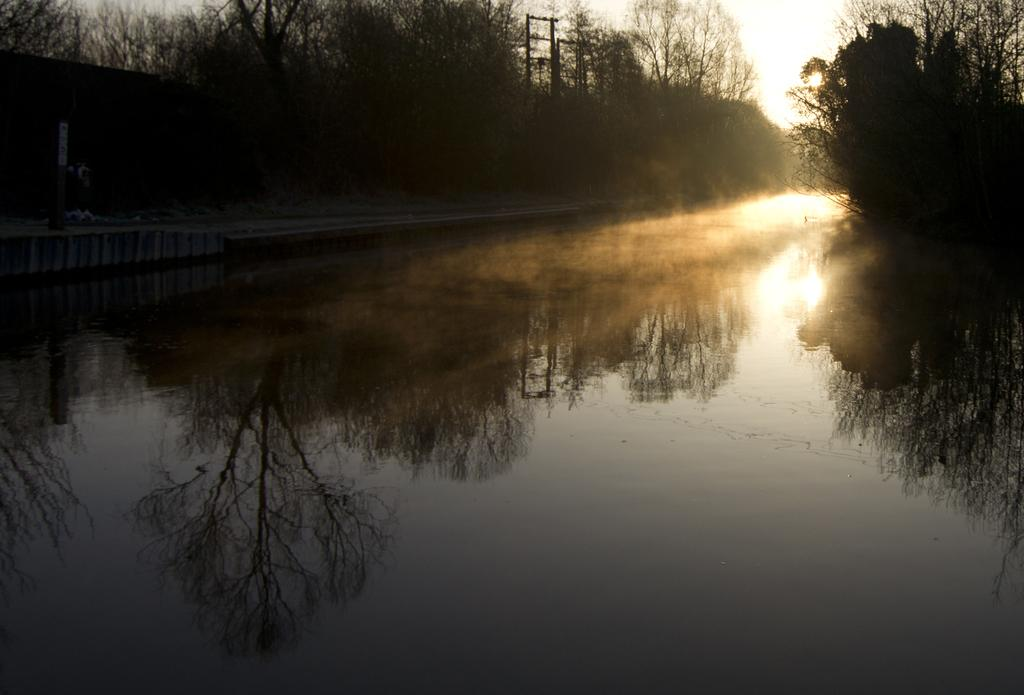What is the primary element visible in the image? There is water in the image. What type of vegetation can be seen in the image? There are trees in the image. What structures are present in the image? Electrical poles are visible in the image. What is the weather like in the image? The sky is cloudy in the image, and sunlight is visible. What type of guitar can be heard playing in the image? There is no guitar or sound present in the image; it is a visual representation of water, trees, electrical poles, and the sky. 